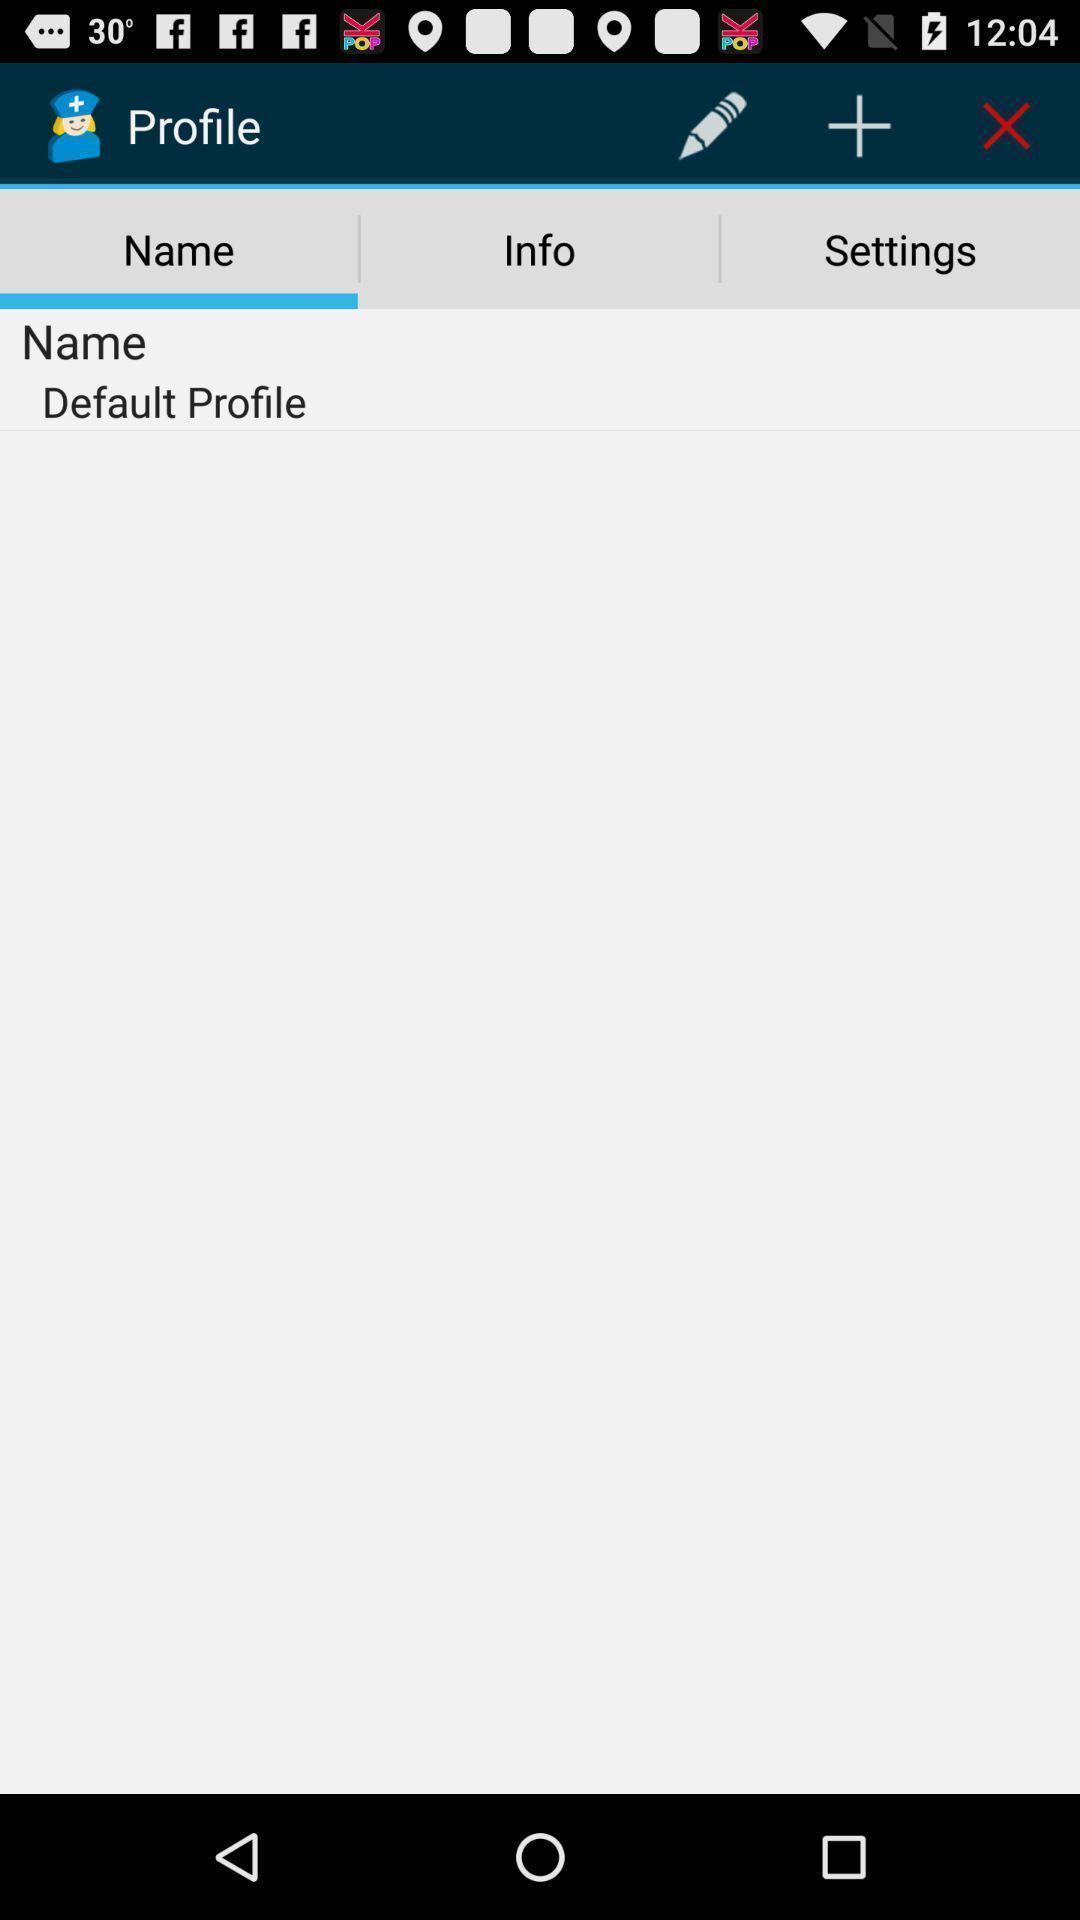What is the overall content of this screenshot? Profile setting page. 